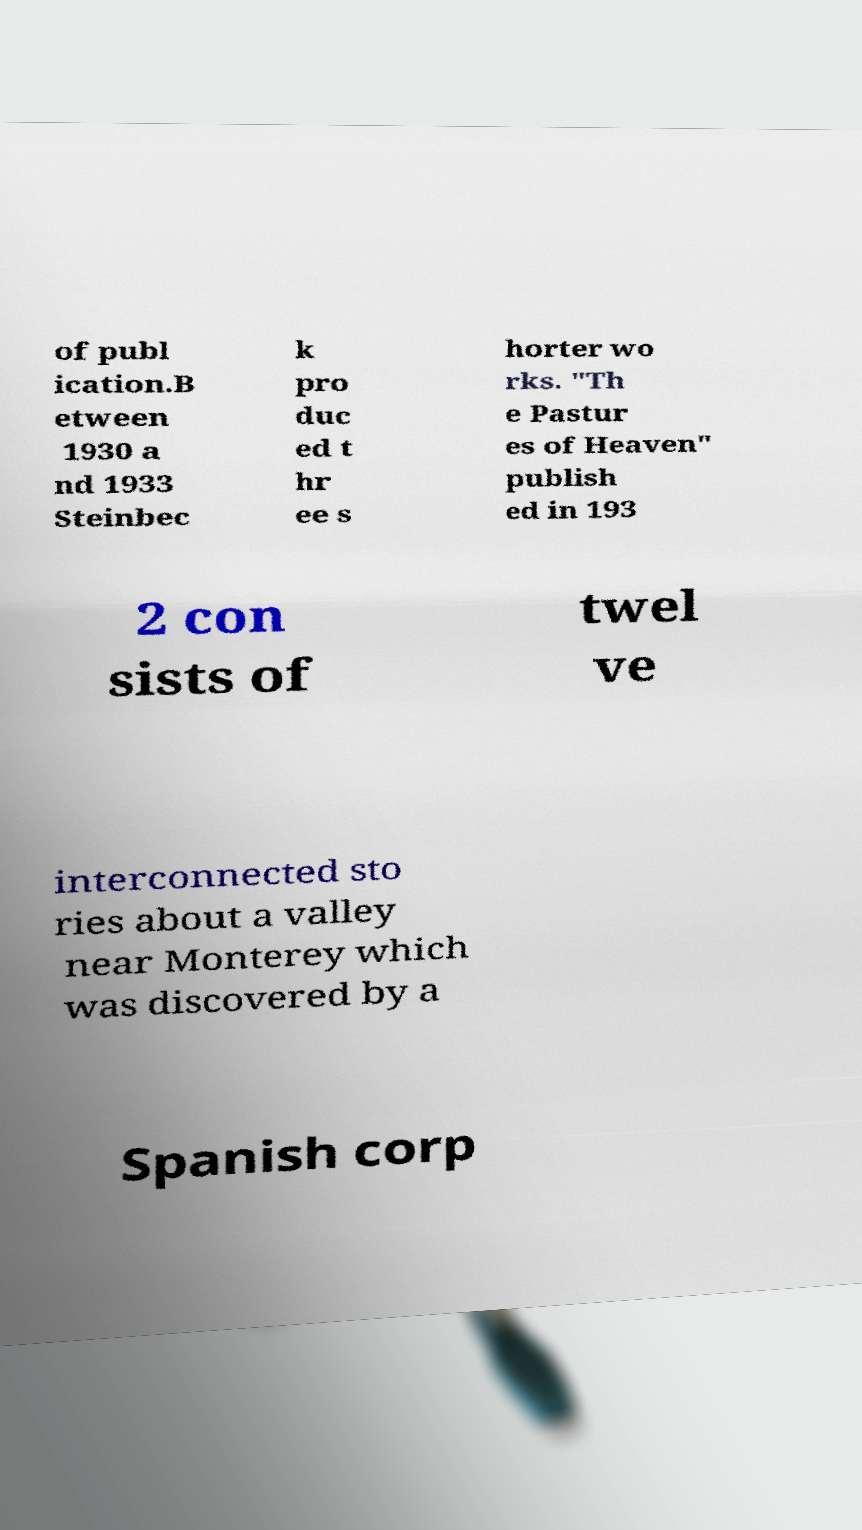For documentation purposes, I need the text within this image transcribed. Could you provide that? of publ ication.B etween 1930 a nd 1933 Steinbec k pro duc ed t hr ee s horter wo rks. "Th e Pastur es of Heaven" publish ed in 193 2 con sists of twel ve interconnected sto ries about a valley near Monterey which was discovered by a Spanish corp 